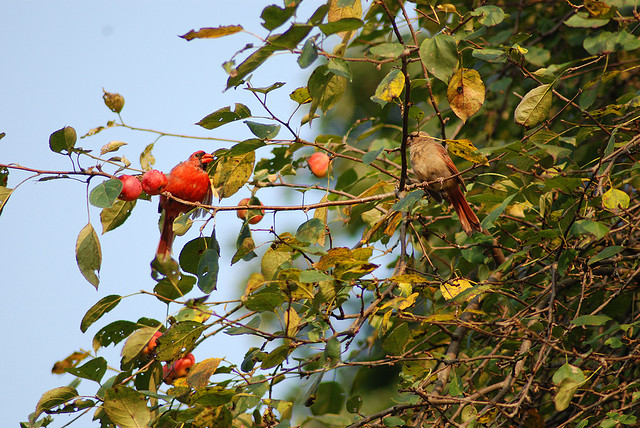<image>Does this show a male and female cardinal? It is unknown if the image shows a male and female cardinal. Does this show a male and female cardinal? I don't know if this shows a male and female cardinal. There are mentions of both male and female cardinals in the answers. 